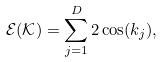<formula> <loc_0><loc_0><loc_500><loc_500>\mathcal { E } ( \mathcal { K } ) = \sum _ { j = 1 } ^ { D } 2 \cos ( k _ { j } ) ,</formula> 